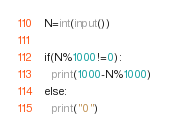Convert code to text. <code><loc_0><loc_0><loc_500><loc_500><_Python_>N=int(input())

if(N%1000!=0):
  print(1000-N%1000)
else:
  print("0")</code> 